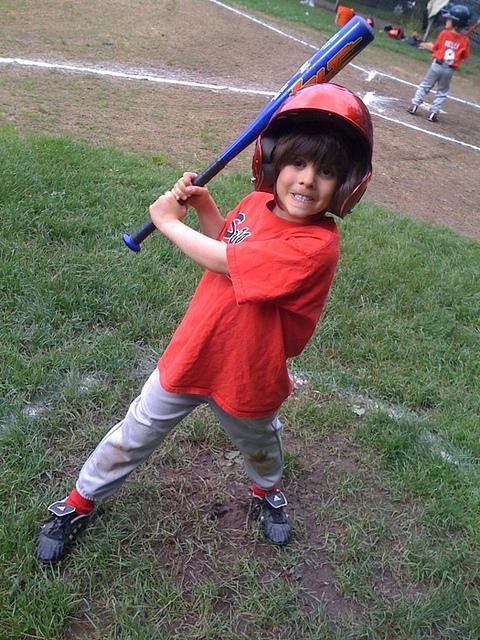What sport is this boy playing?
Short answer required. Baseball. Is this boy using a metal bat?
Give a very brief answer. Yes. Is the boy wearing a blue shirt?
Write a very short answer. No. 